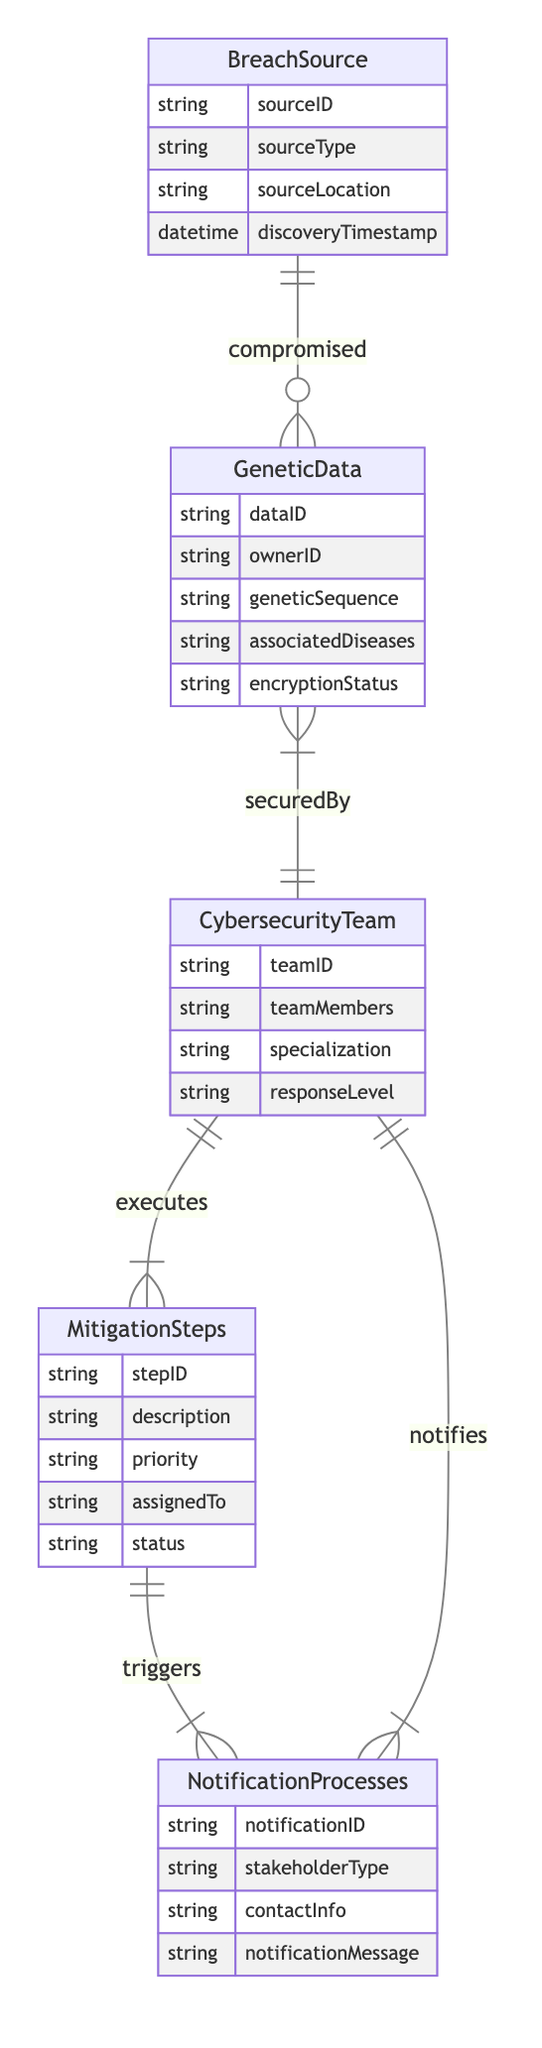What entity is compromised by the Breach Source? The diagram indicates that the relationship between Breach Source and Genetic Data is "compromised." Thus, Genetic Data is the entity that is compromised by the Breach Source.
Answer: Genetic Data How many entities are involved in the diagram? The diagram lists five entities: Breach Source, Genetic Data, Cybersecurity Team, Mitigation Steps, and Notification Processes. Therefore, the total count of entities involved is five.
Answer: 5 What is the relationship type between the Genetic Data and Cybersecurity Team? The diagram shows a relationship between Genetic Data and Cybersecurity Team labeled "securedBy." This indicates how Genetic Data is protected or secured by the Cybersecurity Team.
Answer: securedBy Which entity triggers the Notification Processes? According to the diagram, Mitigation Steps triggers the Notification Processes, establishing that the actions taken during mitigation lead to the initiation of notifications.
Answer: Mitigation Steps What type of notifications does the Cybersecurity Team initiate? The diagram specifies that the Cybersecurity Team notifies through Notification Processes. This points out the role of the Cybersecurity Team in initiating certain notifications related to the breach.
Answer: Notification Processes What is the status attribute of the Mitigation Steps entity? The diagram identifies one of the attributes of the Mitigation Steps entity as "status." This attribute represents the current state or condition of the mitigation actions performed by the Cybersecurity Team.
Answer: status How many relationship types are illustrated in the diagram? The diagram contains four distinct relationship types: compromised, securedBy, executes, and notifies. Thus, the total number of relationship types illustrated is four.
Answer: 4 Which entity is associated with the discovery timestamp in this workflow? The discovery timestamp is an attribute of the Breach Source entity. This attribute indicates when the source of the breach was discovered within the workflow.
Answer: Breach Source What is the priority attribute of the Mitigation Steps? The diagram mentions "priority" as one of the attributes of the Mitigation Steps entity. This represents the level of urgency assigned to each mitigation action during the response workflow.
Answer: priority 